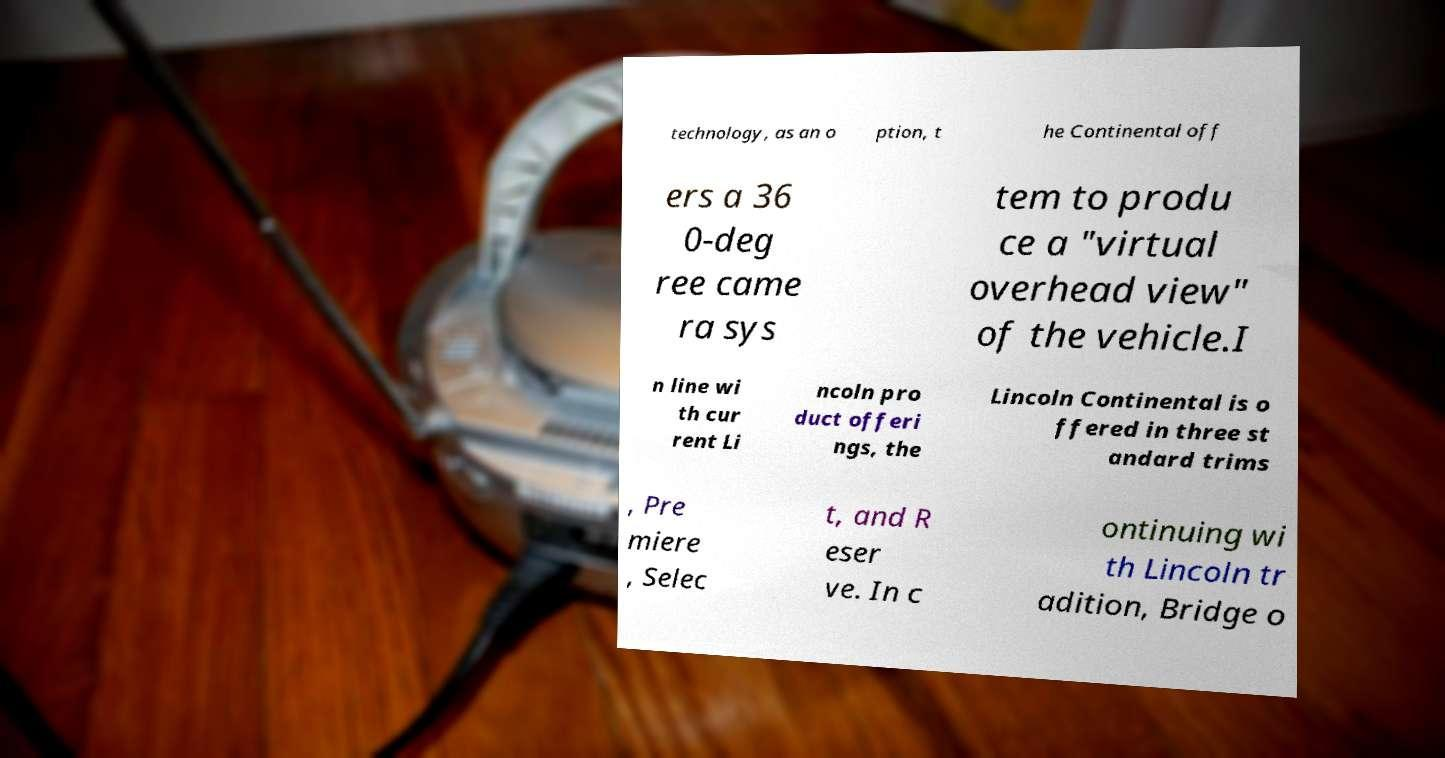There's text embedded in this image that I need extracted. Can you transcribe it verbatim? technology, as an o ption, t he Continental off ers a 36 0-deg ree came ra sys tem to produ ce a "virtual overhead view" of the vehicle.I n line wi th cur rent Li ncoln pro duct offeri ngs, the Lincoln Continental is o ffered in three st andard trims , Pre miere , Selec t, and R eser ve. In c ontinuing wi th Lincoln tr adition, Bridge o 